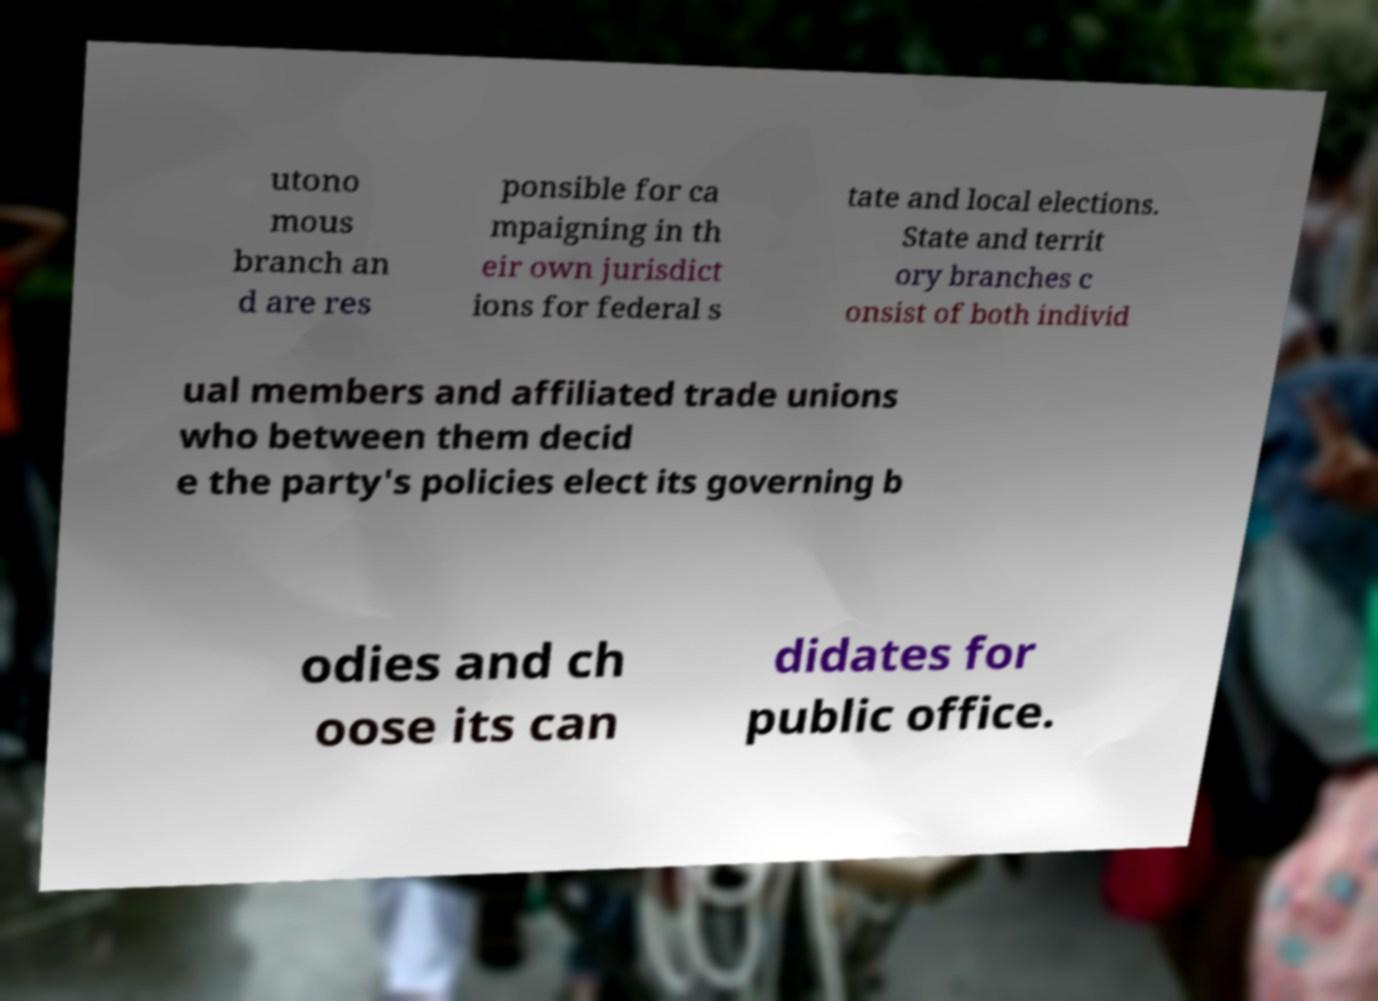Please identify and transcribe the text found in this image. utono mous branch an d are res ponsible for ca mpaigning in th eir own jurisdict ions for federal s tate and local elections. State and territ ory branches c onsist of both individ ual members and affiliated trade unions who between them decid e the party's policies elect its governing b odies and ch oose its can didates for public office. 